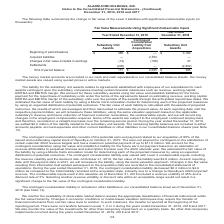According to Alarmcom Holdings's financial document, What was the beginning of period balance of subsidiary unit awards in 2019? According to the financial document, 385 (in thousands). The relevant text states: "sidiary Unit Awards Beginning of period balance $ 385 $ — $ 3,160 Acquired liabilities — 2,793 — Changes in fair value included in earnings (14) (198) 27..." Also, What was the Contingent Consideration Liability from Acquisitions accrued liabilities in 2019? According to the financial document, 2,793 (in thousands). The relevant text states: "balance $ 385 $ — $ 3,160 Acquired liabilities — 2,793 — Changes in fair value included in earnings (14) (198) 27 Settlements (200) — (2,802) End of perio..." Also, Where did the company include their money market accounts in their consolidated balance sheets? cash and cash equivalents. The document states: "The money market accounts are included in our cash and cash equivalents in our consolidated balance sheets. Our money market assets are valued using q..." Also, can you calculate: What was the change in Beginning and ending period balance for Subsidiary Unit Awards in 2018? Based on the calculation: 385-3,160, the result is -2775 (in thousands). This is based on the information: "sidiary Unit Awards Beginning of period balance $ 385 $ — $ 3,160 Acquired liabilities — 2,793 — Changes in fair value included in earnings (14) (198) 27 it Awards Beginning of period balance $ 385 $ ..." The key data points involved are: 3,160, 385. Also, How many years did the beginning of period balance exceed $2,000 thousand? Based on the analysis, there are 1 instances. The counting process: 2018. Also, can you calculate: What was the percentage change in the end of period balance for Subsidiary Unit Awards between 2018 and 2019? To answer this question, I need to perform calculations using the financial data. The calculation is: (171-385)/385, which equals -55.58 (percentage). This is based on the information: "sidiary Unit Awards Beginning of period balance $ 385 $ — $ 3,160 Acquired liabilities — 2,793 — Changes in fair value included in earnings (14) (198) 27 ttlements (200) — (2,802) End of period balanc..." The key data points involved are: 171, 385. 